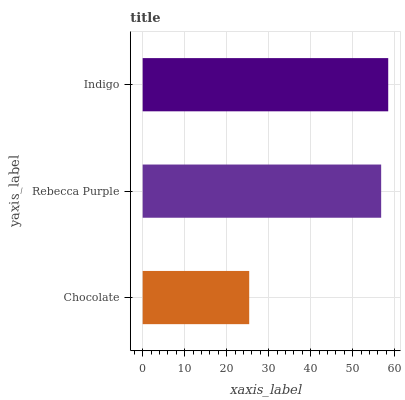Is Chocolate the minimum?
Answer yes or no. Yes. Is Indigo the maximum?
Answer yes or no. Yes. Is Rebecca Purple the minimum?
Answer yes or no. No. Is Rebecca Purple the maximum?
Answer yes or no. No. Is Rebecca Purple greater than Chocolate?
Answer yes or no. Yes. Is Chocolate less than Rebecca Purple?
Answer yes or no. Yes. Is Chocolate greater than Rebecca Purple?
Answer yes or no. No. Is Rebecca Purple less than Chocolate?
Answer yes or no. No. Is Rebecca Purple the high median?
Answer yes or no. Yes. Is Rebecca Purple the low median?
Answer yes or no. Yes. Is Chocolate the high median?
Answer yes or no. No. Is Indigo the low median?
Answer yes or no. No. 